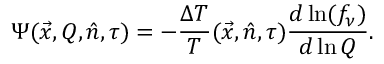Convert formula to latex. <formula><loc_0><loc_0><loc_500><loc_500>\Psi ( \vec { x } , Q , \hat { n } , \tau ) = - \frac { \Delta T } { T } ( \vec { x } , \hat { n } , \tau ) \frac { d \ln ( f _ { \nu } ) } { d \ln Q } .</formula> 